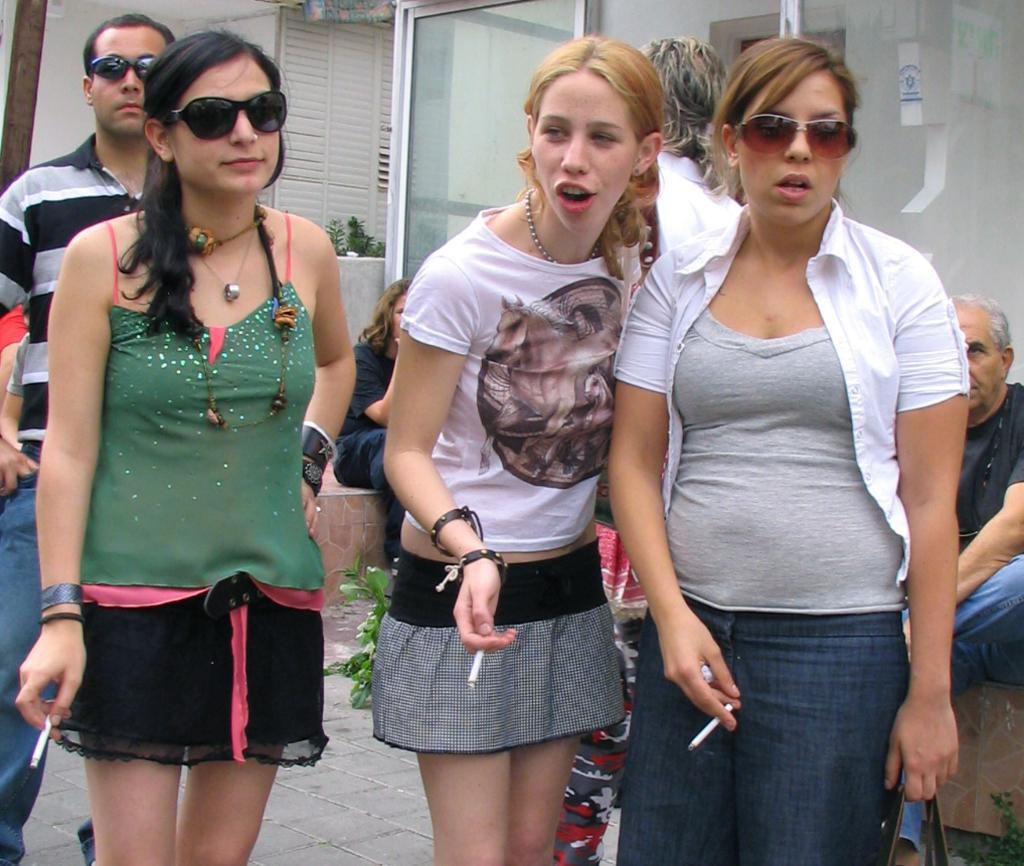How many girls are present in the image? There are three girls in the image. Where are the girls positioned in relation to the image? The girls are standing in the front. What are the girls holding in their hands? The girls are holding cigarettes in their hands. What can be seen in the background of the image? There are glass doors and a white shed house in the background. What is the distribution of the girls' wishes in the image? There is no information about the girls' wishes in the image, so it cannot be determined. 